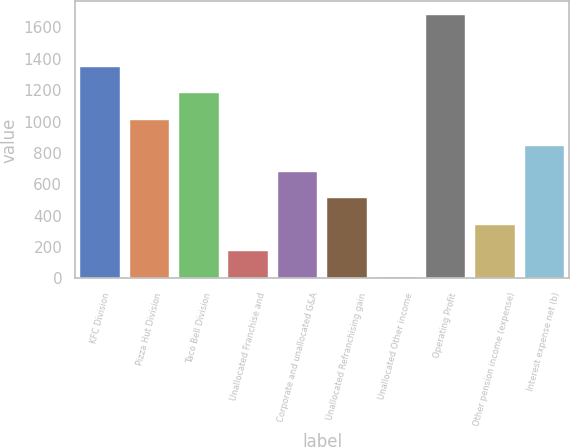<chart> <loc_0><loc_0><loc_500><loc_500><bar_chart><fcel>KFC Division<fcel>Pizza Hut Division<fcel>Taco Bell Division<fcel>Unallocated Franchise and<fcel>Corporate and unallocated G&A<fcel>Unallocated Refranchising gain<fcel>Unallocated Other income<fcel>Operating Profit<fcel>Other pension income (expense)<fcel>Interest expense net (b)<nl><fcel>1347.2<fcel>1012.4<fcel>1179.8<fcel>175.4<fcel>677.6<fcel>510.2<fcel>8<fcel>1682<fcel>342.8<fcel>845<nl></chart> 